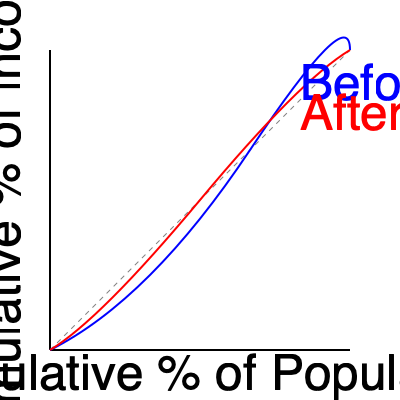Based on the Lorenz curves shown in the graph, how did income inequality change in Spain from before Franco's rule to after his regime? What economic factors during Franco's era might have contributed to this change? To analyze the change in income inequality using Lorenz curves:

1. Interpret the Lorenz curves:
   - The blue curve represents income distribution before Franco's rule
   - The red curve represents income distribution after Franco's rule
   - The diagonal gray line represents perfect equality

2. Compare the curves:
   - The curve closer to the diagonal line indicates less inequality
   - The red curve (after Franco) is closer to the diagonal than the blue curve (before Franco)

3. Conclude about inequality:
   - Income inequality decreased after Franco's rule

4. Economic factors during Franco's era that may have contributed:
   a) Industrialization and economic modernization:
      - Created more jobs and diversified the economy
   b) "Spanish Miracle" (1959-1974):
      - Rapid economic growth and increased foreign investment
   c) Social welfare policies:
      - Introduction of social security systems and labor protections
   d) Education reforms:
      - Increased access to education, potentially leading to better job opportunities
   e) Rural development programs:
      - Reduced urban-rural income disparities

5. Limitations of the analysis:
   - Lorenz curves show relative inequality, not absolute income levels
   - Other factors beyond Franco's policies may have influenced the change

The Lorenz curves suggest a decrease in income inequality, likely due to a combination of economic modernization, growth policies, and social welfare measures implemented during Franco's regime.
Answer: Income inequality decreased after Franco's rule, potentially due to industrialization, economic growth policies, social welfare programs, education reforms, and rural development initiatives during his regime. 